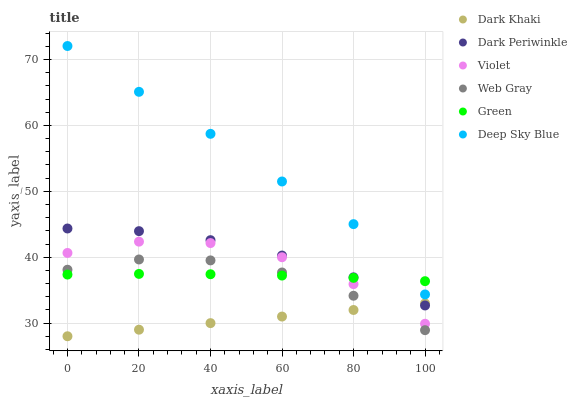Does Dark Khaki have the minimum area under the curve?
Answer yes or no. Yes. Does Deep Sky Blue have the maximum area under the curve?
Answer yes or no. Yes. Does Green have the minimum area under the curve?
Answer yes or no. No. Does Green have the maximum area under the curve?
Answer yes or no. No. Is Dark Khaki the smoothest?
Answer yes or no. Yes. Is Violet the roughest?
Answer yes or no. Yes. Is Green the smoothest?
Answer yes or no. No. Is Green the roughest?
Answer yes or no. No. Does Dark Khaki have the lowest value?
Answer yes or no. Yes. Does Green have the lowest value?
Answer yes or no. No. Does Deep Sky Blue have the highest value?
Answer yes or no. Yes. Does Green have the highest value?
Answer yes or no. No. Is Dark Khaki less than Green?
Answer yes or no. Yes. Is Dark Periwinkle greater than Violet?
Answer yes or no. Yes. Does Web Gray intersect Green?
Answer yes or no. Yes. Is Web Gray less than Green?
Answer yes or no. No. Is Web Gray greater than Green?
Answer yes or no. No. Does Dark Khaki intersect Green?
Answer yes or no. No. 